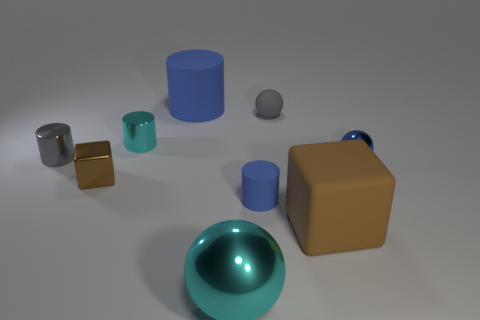How many things are either big blue objects or cyan metallic cylinders?
Your response must be concise. 2. How many gray cubes have the same material as the large cyan object?
Your response must be concise. 0. The other brown thing that is the same shape as the tiny brown thing is what size?
Ensure brevity in your answer.  Large. There is a cyan cylinder; are there any brown rubber cubes left of it?
Offer a very short reply. No. What material is the large cyan sphere?
Ensure brevity in your answer.  Metal. There is a cube that is left of the tiny cyan shiny cylinder; does it have the same color as the large sphere?
Offer a very short reply. No. Is there any other thing that is the same shape as the small cyan object?
Your answer should be compact. Yes. There is a big thing that is the same shape as the small blue metal thing; what color is it?
Your answer should be very brief. Cyan. There is a big thing right of the rubber ball; what is it made of?
Your answer should be compact. Rubber. The big metal thing has what color?
Keep it short and to the point. Cyan. 